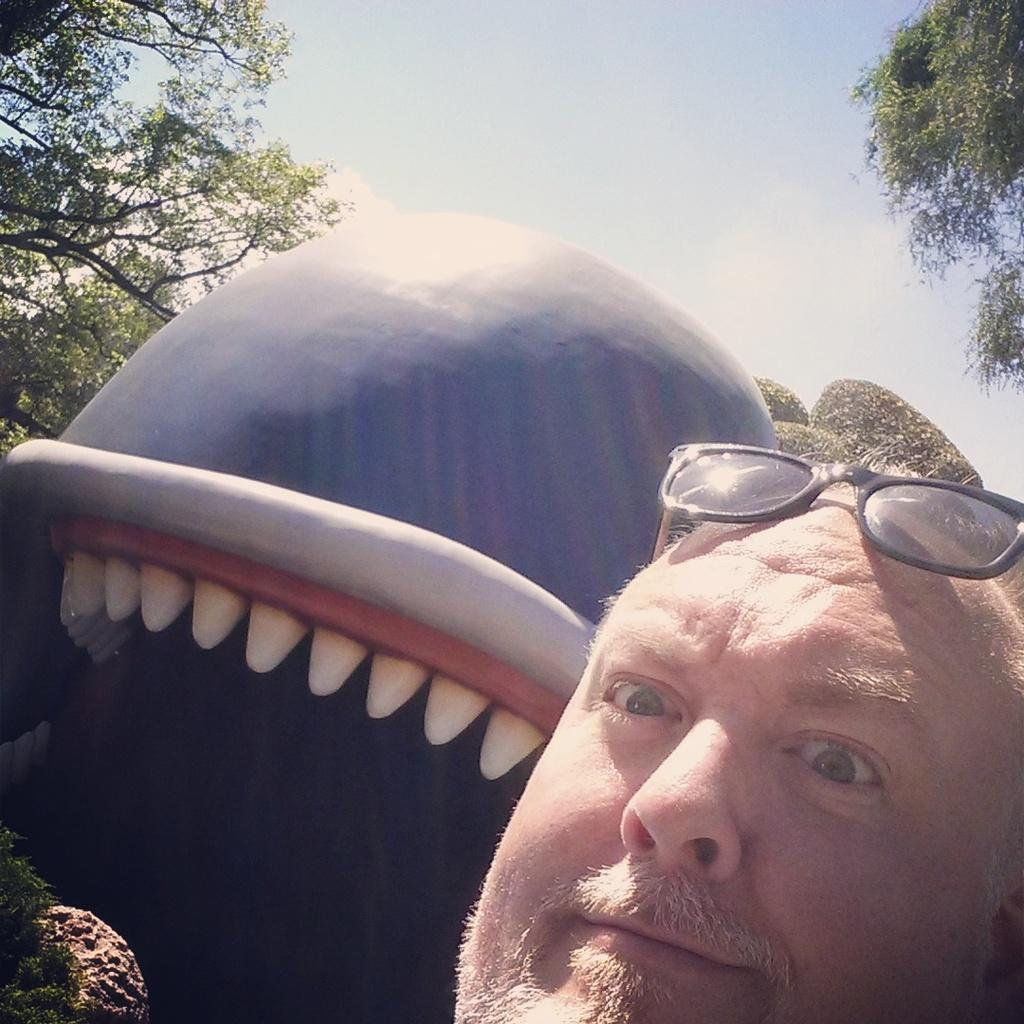Who is present in the image? There is a man in the image. What is the man wearing on his head? The man is wearing shades on his head. What can be seen in the background of the image? There is a blue color thing and trees in the background of the image. What else is visible in the background of the image? The sky is visible in the background of the image. How many bulbs are hanging from the trees in the image? There are no bulbs present in the image; it features a man wearing shades and a background with trees and the sky. 